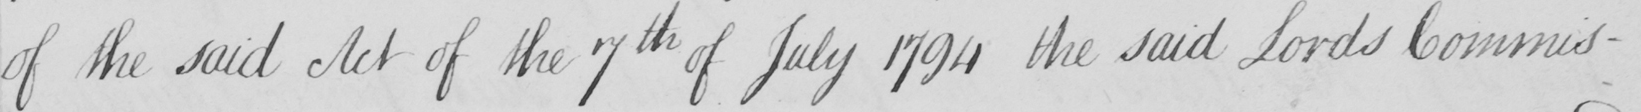Please transcribe the handwritten text in this image. of the said Act of the 7th of July 1794 the said Lords Commis- 